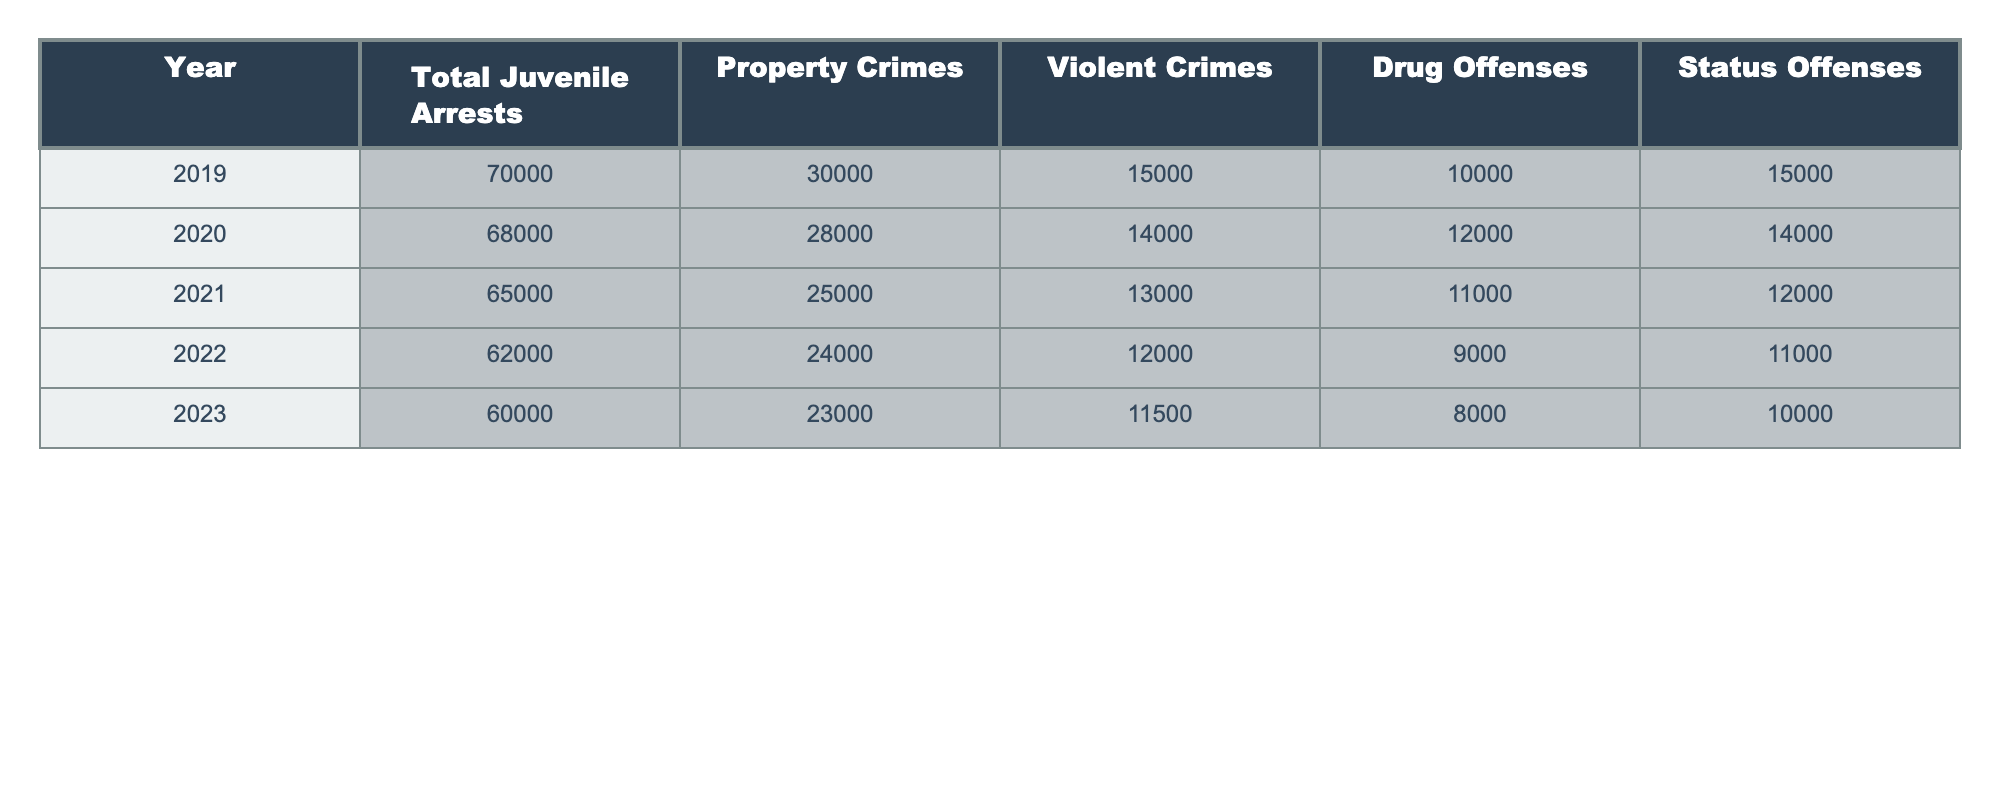What was the total number of juvenile arrests in 2023? Looking at the table, the row for 2023 shows that the total number of juvenile arrests is 60,000.
Answer: 60,000 Which year saw the highest number of property crimes? By examining the property crimes column, the year 2019 has the highest number of property crimes at 30,000.
Answer: 2019 What is the average number of violent crimes over the five years? To find the average, we sum the violent crimes from each year: (15,000 + 14,000 + 13,000 + 12,000 + 11,500) = 65,500. Then, we divide by the number of years (5), which gives us 65,500 / 5 = 13,100.
Answer: 13,100 Did the number of drug offenses increase from 2019 to 2023? Comparing the drug offenses from both years, in 2019 there were 10,000 drug offenses and in 2023 there are 8,000. Since 8,000 is less than 10,000, it shows a decrease.
Answer: No What was the change in total juvenile arrests from 2019 to 2023? The total juvenile arrests in 2019 were 70,000, and in 2023 they were 60,000. The change is calculated as 70,000 - 60,000 = 10,000.
Answer: 10,000 Which year had the lowest number of status offenses? Looking through the status offenses column, it shows that 2023 had the lowest number at 10,000.
Answer: 2023 What percentage decrease in property crimes occurred from 2019 to 2023? In 2019, there were 30,000 property crimes, which decreased to 23,000 in 2023. The decrease is 30,000 - 23,000 = 7,000. To find the percentage decrease, we calculate (7,000 / 30,000) * 100 = 23.33%.
Answer: 23.33% How many total juvenile arrests were made in the two years with the lowest number of arrests? The two years with the lowest total juvenile arrests are 2022 (62,000) and 2023 (60,000). We add these values: 62,000 + 60,000 = 122,000.
Answer: 122,000 In which year was the difference between violent and property crimes the largest? We find the differences for each year: 2019 (15,000 - 30,000 = -15,000), 2020 (14,000 - 28,000 = -14,000), 2021 (13,000 - 25,000 = -12,000), 2022 (12,000 - 24,000 = -12,000), 2023 (11,500 - 23,000 = -11,500). The largest difference occurs in 2019 with -15,000.
Answer: 2019 How does the trend in drug offenses from 2019 to 2023 appear? Over these years, drug offenses decreased from 10,000 in 2019 to 8,000 in 2023. This is a decline, suggesting a downward trend in drug offenses for juveniles.
Answer: Decreasing trend 